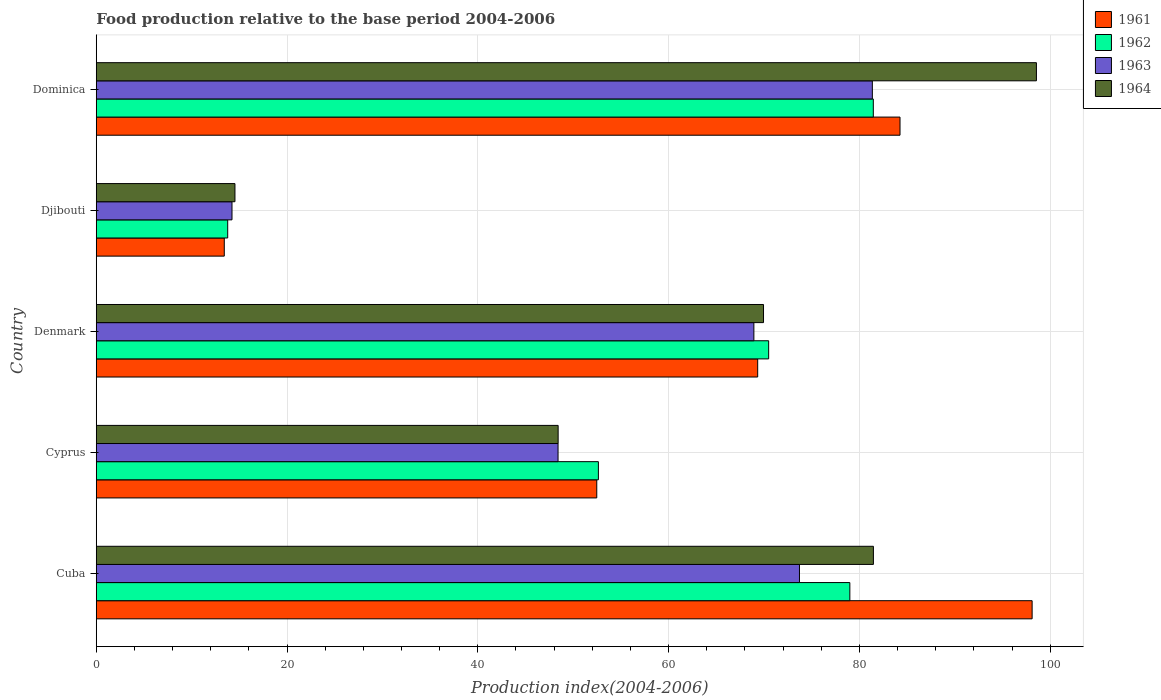How many different coloured bars are there?
Offer a very short reply. 4. How many groups of bars are there?
Provide a succinct answer. 5. Are the number of bars on each tick of the Y-axis equal?
Keep it short and to the point. Yes. How many bars are there on the 4th tick from the top?
Make the answer very short. 4. How many bars are there on the 5th tick from the bottom?
Your answer should be very brief. 4. What is the label of the 3rd group of bars from the top?
Make the answer very short. Denmark. What is the food production index in 1961 in Cuba?
Your answer should be compact. 98.11. Across all countries, what is the maximum food production index in 1964?
Offer a very short reply. 98.56. Across all countries, what is the minimum food production index in 1963?
Offer a terse response. 14.23. In which country was the food production index in 1964 maximum?
Keep it short and to the point. Dominica. In which country was the food production index in 1961 minimum?
Give a very brief answer. Djibouti. What is the total food production index in 1962 in the graph?
Give a very brief answer. 297.37. What is the difference between the food production index in 1961 in Cuba and that in Dominica?
Provide a short and direct response. 13.85. What is the difference between the food production index in 1964 in Dominica and the food production index in 1961 in Djibouti?
Your response must be concise. 85.14. What is the average food production index in 1961 per country?
Make the answer very short. 63.52. What is the difference between the food production index in 1964 and food production index in 1961 in Djibouti?
Provide a short and direct response. 1.12. What is the ratio of the food production index in 1961 in Cuba to that in Denmark?
Your answer should be compact. 1.41. Is the difference between the food production index in 1964 in Djibouti and Dominica greater than the difference between the food production index in 1961 in Djibouti and Dominica?
Provide a succinct answer. No. What is the difference between the highest and the second highest food production index in 1962?
Your response must be concise. 2.46. What is the difference between the highest and the lowest food production index in 1962?
Give a very brief answer. 67.68. What does the 2nd bar from the top in Denmark represents?
Keep it short and to the point. 1963. What does the 4th bar from the bottom in Denmark represents?
Keep it short and to the point. 1964. Is it the case that in every country, the sum of the food production index in 1961 and food production index in 1962 is greater than the food production index in 1963?
Give a very brief answer. Yes. How many bars are there?
Make the answer very short. 20. How many countries are there in the graph?
Provide a succinct answer. 5. Does the graph contain any zero values?
Offer a terse response. No. How are the legend labels stacked?
Your answer should be compact. Vertical. What is the title of the graph?
Offer a very short reply. Food production relative to the base period 2004-2006. Does "2012" appear as one of the legend labels in the graph?
Offer a terse response. No. What is the label or title of the X-axis?
Offer a terse response. Production index(2004-2006). What is the label or title of the Y-axis?
Your answer should be very brief. Country. What is the Production index(2004-2006) of 1961 in Cuba?
Keep it short and to the point. 98.11. What is the Production index(2004-2006) in 1962 in Cuba?
Your answer should be compact. 79. What is the Production index(2004-2006) in 1963 in Cuba?
Offer a very short reply. 73.72. What is the Production index(2004-2006) in 1964 in Cuba?
Your answer should be very brief. 81.47. What is the Production index(2004-2006) of 1961 in Cyprus?
Offer a very short reply. 52.47. What is the Production index(2004-2006) of 1962 in Cyprus?
Your answer should be compact. 52.64. What is the Production index(2004-2006) of 1963 in Cyprus?
Give a very brief answer. 48.41. What is the Production index(2004-2006) of 1964 in Cyprus?
Your answer should be compact. 48.42. What is the Production index(2004-2006) in 1961 in Denmark?
Make the answer very short. 69.34. What is the Production index(2004-2006) in 1962 in Denmark?
Make the answer very short. 70.49. What is the Production index(2004-2006) of 1963 in Denmark?
Ensure brevity in your answer.  68.94. What is the Production index(2004-2006) in 1964 in Denmark?
Provide a short and direct response. 69.95. What is the Production index(2004-2006) in 1961 in Djibouti?
Offer a terse response. 13.42. What is the Production index(2004-2006) of 1962 in Djibouti?
Keep it short and to the point. 13.78. What is the Production index(2004-2006) of 1963 in Djibouti?
Ensure brevity in your answer.  14.23. What is the Production index(2004-2006) of 1964 in Djibouti?
Give a very brief answer. 14.54. What is the Production index(2004-2006) of 1961 in Dominica?
Keep it short and to the point. 84.26. What is the Production index(2004-2006) of 1962 in Dominica?
Your response must be concise. 81.46. What is the Production index(2004-2006) of 1963 in Dominica?
Your answer should be very brief. 81.36. What is the Production index(2004-2006) of 1964 in Dominica?
Offer a terse response. 98.56. Across all countries, what is the maximum Production index(2004-2006) in 1961?
Offer a very short reply. 98.11. Across all countries, what is the maximum Production index(2004-2006) in 1962?
Offer a terse response. 81.46. Across all countries, what is the maximum Production index(2004-2006) of 1963?
Provide a succinct answer. 81.36. Across all countries, what is the maximum Production index(2004-2006) in 1964?
Provide a short and direct response. 98.56. Across all countries, what is the minimum Production index(2004-2006) in 1961?
Provide a succinct answer. 13.42. Across all countries, what is the minimum Production index(2004-2006) of 1962?
Make the answer very short. 13.78. Across all countries, what is the minimum Production index(2004-2006) of 1963?
Provide a succinct answer. 14.23. Across all countries, what is the minimum Production index(2004-2006) in 1964?
Provide a short and direct response. 14.54. What is the total Production index(2004-2006) in 1961 in the graph?
Provide a short and direct response. 317.6. What is the total Production index(2004-2006) of 1962 in the graph?
Give a very brief answer. 297.37. What is the total Production index(2004-2006) in 1963 in the graph?
Provide a short and direct response. 286.66. What is the total Production index(2004-2006) in 1964 in the graph?
Make the answer very short. 312.94. What is the difference between the Production index(2004-2006) in 1961 in Cuba and that in Cyprus?
Make the answer very short. 45.64. What is the difference between the Production index(2004-2006) of 1962 in Cuba and that in Cyprus?
Your answer should be very brief. 26.36. What is the difference between the Production index(2004-2006) in 1963 in Cuba and that in Cyprus?
Provide a short and direct response. 25.31. What is the difference between the Production index(2004-2006) of 1964 in Cuba and that in Cyprus?
Offer a terse response. 33.05. What is the difference between the Production index(2004-2006) of 1961 in Cuba and that in Denmark?
Provide a succinct answer. 28.77. What is the difference between the Production index(2004-2006) of 1962 in Cuba and that in Denmark?
Your response must be concise. 8.51. What is the difference between the Production index(2004-2006) in 1963 in Cuba and that in Denmark?
Your answer should be very brief. 4.78. What is the difference between the Production index(2004-2006) in 1964 in Cuba and that in Denmark?
Your answer should be very brief. 11.52. What is the difference between the Production index(2004-2006) in 1961 in Cuba and that in Djibouti?
Ensure brevity in your answer.  84.69. What is the difference between the Production index(2004-2006) of 1962 in Cuba and that in Djibouti?
Provide a succinct answer. 65.22. What is the difference between the Production index(2004-2006) of 1963 in Cuba and that in Djibouti?
Your response must be concise. 59.49. What is the difference between the Production index(2004-2006) of 1964 in Cuba and that in Djibouti?
Offer a very short reply. 66.93. What is the difference between the Production index(2004-2006) of 1961 in Cuba and that in Dominica?
Make the answer very short. 13.85. What is the difference between the Production index(2004-2006) in 1962 in Cuba and that in Dominica?
Offer a terse response. -2.46. What is the difference between the Production index(2004-2006) in 1963 in Cuba and that in Dominica?
Provide a succinct answer. -7.64. What is the difference between the Production index(2004-2006) of 1964 in Cuba and that in Dominica?
Keep it short and to the point. -17.09. What is the difference between the Production index(2004-2006) of 1961 in Cyprus and that in Denmark?
Ensure brevity in your answer.  -16.87. What is the difference between the Production index(2004-2006) in 1962 in Cyprus and that in Denmark?
Make the answer very short. -17.85. What is the difference between the Production index(2004-2006) in 1963 in Cyprus and that in Denmark?
Your response must be concise. -20.53. What is the difference between the Production index(2004-2006) of 1964 in Cyprus and that in Denmark?
Offer a very short reply. -21.53. What is the difference between the Production index(2004-2006) of 1961 in Cyprus and that in Djibouti?
Your answer should be very brief. 39.05. What is the difference between the Production index(2004-2006) of 1962 in Cyprus and that in Djibouti?
Ensure brevity in your answer.  38.86. What is the difference between the Production index(2004-2006) of 1963 in Cyprus and that in Djibouti?
Your answer should be compact. 34.18. What is the difference between the Production index(2004-2006) in 1964 in Cyprus and that in Djibouti?
Ensure brevity in your answer.  33.88. What is the difference between the Production index(2004-2006) of 1961 in Cyprus and that in Dominica?
Make the answer very short. -31.79. What is the difference between the Production index(2004-2006) of 1962 in Cyprus and that in Dominica?
Provide a short and direct response. -28.82. What is the difference between the Production index(2004-2006) of 1963 in Cyprus and that in Dominica?
Provide a short and direct response. -32.95. What is the difference between the Production index(2004-2006) in 1964 in Cyprus and that in Dominica?
Offer a terse response. -50.14. What is the difference between the Production index(2004-2006) of 1961 in Denmark and that in Djibouti?
Provide a short and direct response. 55.92. What is the difference between the Production index(2004-2006) in 1962 in Denmark and that in Djibouti?
Your answer should be very brief. 56.71. What is the difference between the Production index(2004-2006) of 1963 in Denmark and that in Djibouti?
Your answer should be compact. 54.71. What is the difference between the Production index(2004-2006) in 1964 in Denmark and that in Djibouti?
Ensure brevity in your answer.  55.41. What is the difference between the Production index(2004-2006) in 1961 in Denmark and that in Dominica?
Provide a short and direct response. -14.92. What is the difference between the Production index(2004-2006) in 1962 in Denmark and that in Dominica?
Your answer should be very brief. -10.97. What is the difference between the Production index(2004-2006) in 1963 in Denmark and that in Dominica?
Provide a succinct answer. -12.42. What is the difference between the Production index(2004-2006) of 1964 in Denmark and that in Dominica?
Your answer should be very brief. -28.61. What is the difference between the Production index(2004-2006) in 1961 in Djibouti and that in Dominica?
Provide a succinct answer. -70.84. What is the difference between the Production index(2004-2006) in 1962 in Djibouti and that in Dominica?
Your response must be concise. -67.68. What is the difference between the Production index(2004-2006) in 1963 in Djibouti and that in Dominica?
Offer a terse response. -67.13. What is the difference between the Production index(2004-2006) in 1964 in Djibouti and that in Dominica?
Your answer should be very brief. -84.02. What is the difference between the Production index(2004-2006) of 1961 in Cuba and the Production index(2004-2006) of 1962 in Cyprus?
Give a very brief answer. 45.47. What is the difference between the Production index(2004-2006) in 1961 in Cuba and the Production index(2004-2006) in 1963 in Cyprus?
Offer a terse response. 49.7. What is the difference between the Production index(2004-2006) of 1961 in Cuba and the Production index(2004-2006) of 1964 in Cyprus?
Give a very brief answer. 49.69. What is the difference between the Production index(2004-2006) in 1962 in Cuba and the Production index(2004-2006) in 1963 in Cyprus?
Provide a succinct answer. 30.59. What is the difference between the Production index(2004-2006) of 1962 in Cuba and the Production index(2004-2006) of 1964 in Cyprus?
Your response must be concise. 30.58. What is the difference between the Production index(2004-2006) in 1963 in Cuba and the Production index(2004-2006) in 1964 in Cyprus?
Give a very brief answer. 25.3. What is the difference between the Production index(2004-2006) in 1961 in Cuba and the Production index(2004-2006) in 1962 in Denmark?
Keep it short and to the point. 27.62. What is the difference between the Production index(2004-2006) in 1961 in Cuba and the Production index(2004-2006) in 1963 in Denmark?
Your response must be concise. 29.17. What is the difference between the Production index(2004-2006) of 1961 in Cuba and the Production index(2004-2006) of 1964 in Denmark?
Your answer should be very brief. 28.16. What is the difference between the Production index(2004-2006) in 1962 in Cuba and the Production index(2004-2006) in 1963 in Denmark?
Make the answer very short. 10.06. What is the difference between the Production index(2004-2006) of 1962 in Cuba and the Production index(2004-2006) of 1964 in Denmark?
Your response must be concise. 9.05. What is the difference between the Production index(2004-2006) in 1963 in Cuba and the Production index(2004-2006) in 1964 in Denmark?
Give a very brief answer. 3.77. What is the difference between the Production index(2004-2006) in 1961 in Cuba and the Production index(2004-2006) in 1962 in Djibouti?
Offer a terse response. 84.33. What is the difference between the Production index(2004-2006) in 1961 in Cuba and the Production index(2004-2006) in 1963 in Djibouti?
Make the answer very short. 83.88. What is the difference between the Production index(2004-2006) of 1961 in Cuba and the Production index(2004-2006) of 1964 in Djibouti?
Offer a terse response. 83.57. What is the difference between the Production index(2004-2006) of 1962 in Cuba and the Production index(2004-2006) of 1963 in Djibouti?
Give a very brief answer. 64.77. What is the difference between the Production index(2004-2006) in 1962 in Cuba and the Production index(2004-2006) in 1964 in Djibouti?
Provide a short and direct response. 64.46. What is the difference between the Production index(2004-2006) in 1963 in Cuba and the Production index(2004-2006) in 1964 in Djibouti?
Your response must be concise. 59.18. What is the difference between the Production index(2004-2006) in 1961 in Cuba and the Production index(2004-2006) in 1962 in Dominica?
Keep it short and to the point. 16.65. What is the difference between the Production index(2004-2006) in 1961 in Cuba and the Production index(2004-2006) in 1963 in Dominica?
Make the answer very short. 16.75. What is the difference between the Production index(2004-2006) of 1961 in Cuba and the Production index(2004-2006) of 1964 in Dominica?
Provide a succinct answer. -0.45. What is the difference between the Production index(2004-2006) in 1962 in Cuba and the Production index(2004-2006) in 1963 in Dominica?
Your answer should be very brief. -2.36. What is the difference between the Production index(2004-2006) of 1962 in Cuba and the Production index(2004-2006) of 1964 in Dominica?
Make the answer very short. -19.56. What is the difference between the Production index(2004-2006) of 1963 in Cuba and the Production index(2004-2006) of 1964 in Dominica?
Provide a succinct answer. -24.84. What is the difference between the Production index(2004-2006) of 1961 in Cyprus and the Production index(2004-2006) of 1962 in Denmark?
Offer a terse response. -18.02. What is the difference between the Production index(2004-2006) in 1961 in Cyprus and the Production index(2004-2006) in 1963 in Denmark?
Provide a short and direct response. -16.47. What is the difference between the Production index(2004-2006) in 1961 in Cyprus and the Production index(2004-2006) in 1964 in Denmark?
Give a very brief answer. -17.48. What is the difference between the Production index(2004-2006) in 1962 in Cyprus and the Production index(2004-2006) in 1963 in Denmark?
Provide a short and direct response. -16.3. What is the difference between the Production index(2004-2006) of 1962 in Cyprus and the Production index(2004-2006) of 1964 in Denmark?
Your response must be concise. -17.31. What is the difference between the Production index(2004-2006) in 1963 in Cyprus and the Production index(2004-2006) in 1964 in Denmark?
Your response must be concise. -21.54. What is the difference between the Production index(2004-2006) in 1961 in Cyprus and the Production index(2004-2006) in 1962 in Djibouti?
Offer a terse response. 38.69. What is the difference between the Production index(2004-2006) of 1961 in Cyprus and the Production index(2004-2006) of 1963 in Djibouti?
Your answer should be very brief. 38.24. What is the difference between the Production index(2004-2006) in 1961 in Cyprus and the Production index(2004-2006) in 1964 in Djibouti?
Provide a succinct answer. 37.93. What is the difference between the Production index(2004-2006) in 1962 in Cyprus and the Production index(2004-2006) in 1963 in Djibouti?
Give a very brief answer. 38.41. What is the difference between the Production index(2004-2006) of 1962 in Cyprus and the Production index(2004-2006) of 1964 in Djibouti?
Your answer should be very brief. 38.1. What is the difference between the Production index(2004-2006) in 1963 in Cyprus and the Production index(2004-2006) in 1964 in Djibouti?
Provide a succinct answer. 33.87. What is the difference between the Production index(2004-2006) of 1961 in Cyprus and the Production index(2004-2006) of 1962 in Dominica?
Make the answer very short. -28.99. What is the difference between the Production index(2004-2006) in 1961 in Cyprus and the Production index(2004-2006) in 1963 in Dominica?
Your response must be concise. -28.89. What is the difference between the Production index(2004-2006) in 1961 in Cyprus and the Production index(2004-2006) in 1964 in Dominica?
Your response must be concise. -46.09. What is the difference between the Production index(2004-2006) of 1962 in Cyprus and the Production index(2004-2006) of 1963 in Dominica?
Give a very brief answer. -28.72. What is the difference between the Production index(2004-2006) in 1962 in Cyprus and the Production index(2004-2006) in 1964 in Dominica?
Offer a terse response. -45.92. What is the difference between the Production index(2004-2006) of 1963 in Cyprus and the Production index(2004-2006) of 1964 in Dominica?
Provide a short and direct response. -50.15. What is the difference between the Production index(2004-2006) in 1961 in Denmark and the Production index(2004-2006) in 1962 in Djibouti?
Provide a succinct answer. 55.56. What is the difference between the Production index(2004-2006) of 1961 in Denmark and the Production index(2004-2006) of 1963 in Djibouti?
Your answer should be compact. 55.11. What is the difference between the Production index(2004-2006) in 1961 in Denmark and the Production index(2004-2006) in 1964 in Djibouti?
Offer a very short reply. 54.8. What is the difference between the Production index(2004-2006) in 1962 in Denmark and the Production index(2004-2006) in 1963 in Djibouti?
Offer a very short reply. 56.26. What is the difference between the Production index(2004-2006) of 1962 in Denmark and the Production index(2004-2006) of 1964 in Djibouti?
Keep it short and to the point. 55.95. What is the difference between the Production index(2004-2006) in 1963 in Denmark and the Production index(2004-2006) in 1964 in Djibouti?
Provide a short and direct response. 54.4. What is the difference between the Production index(2004-2006) in 1961 in Denmark and the Production index(2004-2006) in 1962 in Dominica?
Your response must be concise. -12.12. What is the difference between the Production index(2004-2006) of 1961 in Denmark and the Production index(2004-2006) of 1963 in Dominica?
Offer a terse response. -12.02. What is the difference between the Production index(2004-2006) in 1961 in Denmark and the Production index(2004-2006) in 1964 in Dominica?
Keep it short and to the point. -29.22. What is the difference between the Production index(2004-2006) in 1962 in Denmark and the Production index(2004-2006) in 1963 in Dominica?
Give a very brief answer. -10.87. What is the difference between the Production index(2004-2006) in 1962 in Denmark and the Production index(2004-2006) in 1964 in Dominica?
Offer a very short reply. -28.07. What is the difference between the Production index(2004-2006) in 1963 in Denmark and the Production index(2004-2006) in 1964 in Dominica?
Your answer should be very brief. -29.62. What is the difference between the Production index(2004-2006) of 1961 in Djibouti and the Production index(2004-2006) of 1962 in Dominica?
Offer a terse response. -68.04. What is the difference between the Production index(2004-2006) in 1961 in Djibouti and the Production index(2004-2006) in 1963 in Dominica?
Ensure brevity in your answer.  -67.94. What is the difference between the Production index(2004-2006) of 1961 in Djibouti and the Production index(2004-2006) of 1964 in Dominica?
Provide a succinct answer. -85.14. What is the difference between the Production index(2004-2006) of 1962 in Djibouti and the Production index(2004-2006) of 1963 in Dominica?
Give a very brief answer. -67.58. What is the difference between the Production index(2004-2006) in 1962 in Djibouti and the Production index(2004-2006) in 1964 in Dominica?
Ensure brevity in your answer.  -84.78. What is the difference between the Production index(2004-2006) of 1963 in Djibouti and the Production index(2004-2006) of 1964 in Dominica?
Offer a very short reply. -84.33. What is the average Production index(2004-2006) of 1961 per country?
Ensure brevity in your answer.  63.52. What is the average Production index(2004-2006) in 1962 per country?
Your answer should be compact. 59.47. What is the average Production index(2004-2006) of 1963 per country?
Make the answer very short. 57.33. What is the average Production index(2004-2006) in 1964 per country?
Offer a terse response. 62.59. What is the difference between the Production index(2004-2006) of 1961 and Production index(2004-2006) of 1962 in Cuba?
Your answer should be compact. 19.11. What is the difference between the Production index(2004-2006) in 1961 and Production index(2004-2006) in 1963 in Cuba?
Your answer should be compact. 24.39. What is the difference between the Production index(2004-2006) in 1961 and Production index(2004-2006) in 1964 in Cuba?
Make the answer very short. 16.64. What is the difference between the Production index(2004-2006) in 1962 and Production index(2004-2006) in 1963 in Cuba?
Make the answer very short. 5.28. What is the difference between the Production index(2004-2006) of 1962 and Production index(2004-2006) of 1964 in Cuba?
Give a very brief answer. -2.47. What is the difference between the Production index(2004-2006) of 1963 and Production index(2004-2006) of 1964 in Cuba?
Offer a terse response. -7.75. What is the difference between the Production index(2004-2006) of 1961 and Production index(2004-2006) of 1962 in Cyprus?
Make the answer very short. -0.17. What is the difference between the Production index(2004-2006) in 1961 and Production index(2004-2006) in 1963 in Cyprus?
Provide a short and direct response. 4.06. What is the difference between the Production index(2004-2006) in 1961 and Production index(2004-2006) in 1964 in Cyprus?
Make the answer very short. 4.05. What is the difference between the Production index(2004-2006) of 1962 and Production index(2004-2006) of 1963 in Cyprus?
Make the answer very short. 4.23. What is the difference between the Production index(2004-2006) of 1962 and Production index(2004-2006) of 1964 in Cyprus?
Keep it short and to the point. 4.22. What is the difference between the Production index(2004-2006) of 1963 and Production index(2004-2006) of 1964 in Cyprus?
Offer a very short reply. -0.01. What is the difference between the Production index(2004-2006) in 1961 and Production index(2004-2006) in 1962 in Denmark?
Your response must be concise. -1.15. What is the difference between the Production index(2004-2006) of 1961 and Production index(2004-2006) of 1964 in Denmark?
Offer a terse response. -0.61. What is the difference between the Production index(2004-2006) of 1962 and Production index(2004-2006) of 1963 in Denmark?
Provide a succinct answer. 1.55. What is the difference between the Production index(2004-2006) of 1962 and Production index(2004-2006) of 1964 in Denmark?
Your answer should be compact. 0.54. What is the difference between the Production index(2004-2006) of 1963 and Production index(2004-2006) of 1964 in Denmark?
Offer a very short reply. -1.01. What is the difference between the Production index(2004-2006) of 1961 and Production index(2004-2006) of 1962 in Djibouti?
Your answer should be very brief. -0.36. What is the difference between the Production index(2004-2006) of 1961 and Production index(2004-2006) of 1963 in Djibouti?
Keep it short and to the point. -0.81. What is the difference between the Production index(2004-2006) of 1961 and Production index(2004-2006) of 1964 in Djibouti?
Ensure brevity in your answer.  -1.12. What is the difference between the Production index(2004-2006) in 1962 and Production index(2004-2006) in 1963 in Djibouti?
Your response must be concise. -0.45. What is the difference between the Production index(2004-2006) of 1962 and Production index(2004-2006) of 1964 in Djibouti?
Provide a short and direct response. -0.76. What is the difference between the Production index(2004-2006) in 1963 and Production index(2004-2006) in 1964 in Djibouti?
Give a very brief answer. -0.31. What is the difference between the Production index(2004-2006) in 1961 and Production index(2004-2006) in 1962 in Dominica?
Ensure brevity in your answer.  2.8. What is the difference between the Production index(2004-2006) in 1961 and Production index(2004-2006) in 1964 in Dominica?
Provide a short and direct response. -14.3. What is the difference between the Production index(2004-2006) of 1962 and Production index(2004-2006) of 1964 in Dominica?
Keep it short and to the point. -17.1. What is the difference between the Production index(2004-2006) in 1963 and Production index(2004-2006) in 1964 in Dominica?
Your answer should be very brief. -17.2. What is the ratio of the Production index(2004-2006) of 1961 in Cuba to that in Cyprus?
Your answer should be compact. 1.87. What is the ratio of the Production index(2004-2006) in 1962 in Cuba to that in Cyprus?
Keep it short and to the point. 1.5. What is the ratio of the Production index(2004-2006) in 1963 in Cuba to that in Cyprus?
Your response must be concise. 1.52. What is the ratio of the Production index(2004-2006) of 1964 in Cuba to that in Cyprus?
Offer a terse response. 1.68. What is the ratio of the Production index(2004-2006) of 1961 in Cuba to that in Denmark?
Your answer should be very brief. 1.41. What is the ratio of the Production index(2004-2006) of 1962 in Cuba to that in Denmark?
Ensure brevity in your answer.  1.12. What is the ratio of the Production index(2004-2006) of 1963 in Cuba to that in Denmark?
Give a very brief answer. 1.07. What is the ratio of the Production index(2004-2006) of 1964 in Cuba to that in Denmark?
Offer a very short reply. 1.16. What is the ratio of the Production index(2004-2006) of 1961 in Cuba to that in Djibouti?
Your answer should be very brief. 7.31. What is the ratio of the Production index(2004-2006) in 1962 in Cuba to that in Djibouti?
Make the answer very short. 5.73. What is the ratio of the Production index(2004-2006) in 1963 in Cuba to that in Djibouti?
Your answer should be compact. 5.18. What is the ratio of the Production index(2004-2006) of 1964 in Cuba to that in Djibouti?
Give a very brief answer. 5.6. What is the ratio of the Production index(2004-2006) in 1961 in Cuba to that in Dominica?
Keep it short and to the point. 1.16. What is the ratio of the Production index(2004-2006) in 1962 in Cuba to that in Dominica?
Your answer should be very brief. 0.97. What is the ratio of the Production index(2004-2006) in 1963 in Cuba to that in Dominica?
Make the answer very short. 0.91. What is the ratio of the Production index(2004-2006) in 1964 in Cuba to that in Dominica?
Provide a succinct answer. 0.83. What is the ratio of the Production index(2004-2006) in 1961 in Cyprus to that in Denmark?
Keep it short and to the point. 0.76. What is the ratio of the Production index(2004-2006) of 1962 in Cyprus to that in Denmark?
Offer a very short reply. 0.75. What is the ratio of the Production index(2004-2006) in 1963 in Cyprus to that in Denmark?
Your answer should be compact. 0.7. What is the ratio of the Production index(2004-2006) of 1964 in Cyprus to that in Denmark?
Provide a succinct answer. 0.69. What is the ratio of the Production index(2004-2006) of 1961 in Cyprus to that in Djibouti?
Offer a terse response. 3.91. What is the ratio of the Production index(2004-2006) of 1962 in Cyprus to that in Djibouti?
Offer a very short reply. 3.82. What is the ratio of the Production index(2004-2006) of 1963 in Cyprus to that in Djibouti?
Ensure brevity in your answer.  3.4. What is the ratio of the Production index(2004-2006) of 1964 in Cyprus to that in Djibouti?
Your answer should be compact. 3.33. What is the ratio of the Production index(2004-2006) in 1961 in Cyprus to that in Dominica?
Give a very brief answer. 0.62. What is the ratio of the Production index(2004-2006) of 1962 in Cyprus to that in Dominica?
Make the answer very short. 0.65. What is the ratio of the Production index(2004-2006) of 1963 in Cyprus to that in Dominica?
Your answer should be very brief. 0.59. What is the ratio of the Production index(2004-2006) in 1964 in Cyprus to that in Dominica?
Your answer should be very brief. 0.49. What is the ratio of the Production index(2004-2006) of 1961 in Denmark to that in Djibouti?
Provide a succinct answer. 5.17. What is the ratio of the Production index(2004-2006) of 1962 in Denmark to that in Djibouti?
Keep it short and to the point. 5.12. What is the ratio of the Production index(2004-2006) of 1963 in Denmark to that in Djibouti?
Your answer should be very brief. 4.84. What is the ratio of the Production index(2004-2006) of 1964 in Denmark to that in Djibouti?
Provide a short and direct response. 4.81. What is the ratio of the Production index(2004-2006) in 1961 in Denmark to that in Dominica?
Give a very brief answer. 0.82. What is the ratio of the Production index(2004-2006) of 1962 in Denmark to that in Dominica?
Provide a succinct answer. 0.87. What is the ratio of the Production index(2004-2006) in 1963 in Denmark to that in Dominica?
Keep it short and to the point. 0.85. What is the ratio of the Production index(2004-2006) of 1964 in Denmark to that in Dominica?
Your answer should be very brief. 0.71. What is the ratio of the Production index(2004-2006) in 1961 in Djibouti to that in Dominica?
Your response must be concise. 0.16. What is the ratio of the Production index(2004-2006) in 1962 in Djibouti to that in Dominica?
Offer a very short reply. 0.17. What is the ratio of the Production index(2004-2006) in 1963 in Djibouti to that in Dominica?
Offer a terse response. 0.17. What is the ratio of the Production index(2004-2006) in 1964 in Djibouti to that in Dominica?
Your answer should be very brief. 0.15. What is the difference between the highest and the second highest Production index(2004-2006) of 1961?
Keep it short and to the point. 13.85. What is the difference between the highest and the second highest Production index(2004-2006) of 1962?
Keep it short and to the point. 2.46. What is the difference between the highest and the second highest Production index(2004-2006) of 1963?
Your answer should be very brief. 7.64. What is the difference between the highest and the second highest Production index(2004-2006) of 1964?
Offer a very short reply. 17.09. What is the difference between the highest and the lowest Production index(2004-2006) of 1961?
Offer a very short reply. 84.69. What is the difference between the highest and the lowest Production index(2004-2006) in 1962?
Give a very brief answer. 67.68. What is the difference between the highest and the lowest Production index(2004-2006) of 1963?
Make the answer very short. 67.13. What is the difference between the highest and the lowest Production index(2004-2006) in 1964?
Give a very brief answer. 84.02. 